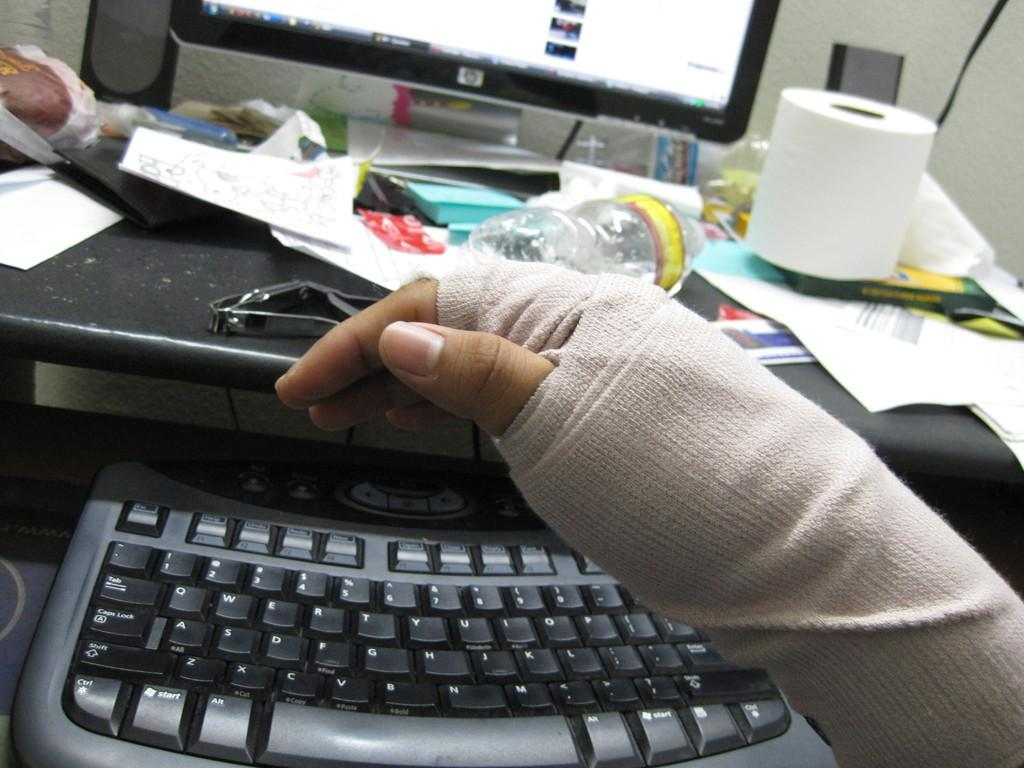<image>
Create a compact narrative representing the image presented. Person with a broken hand in front of a HP monitor. 